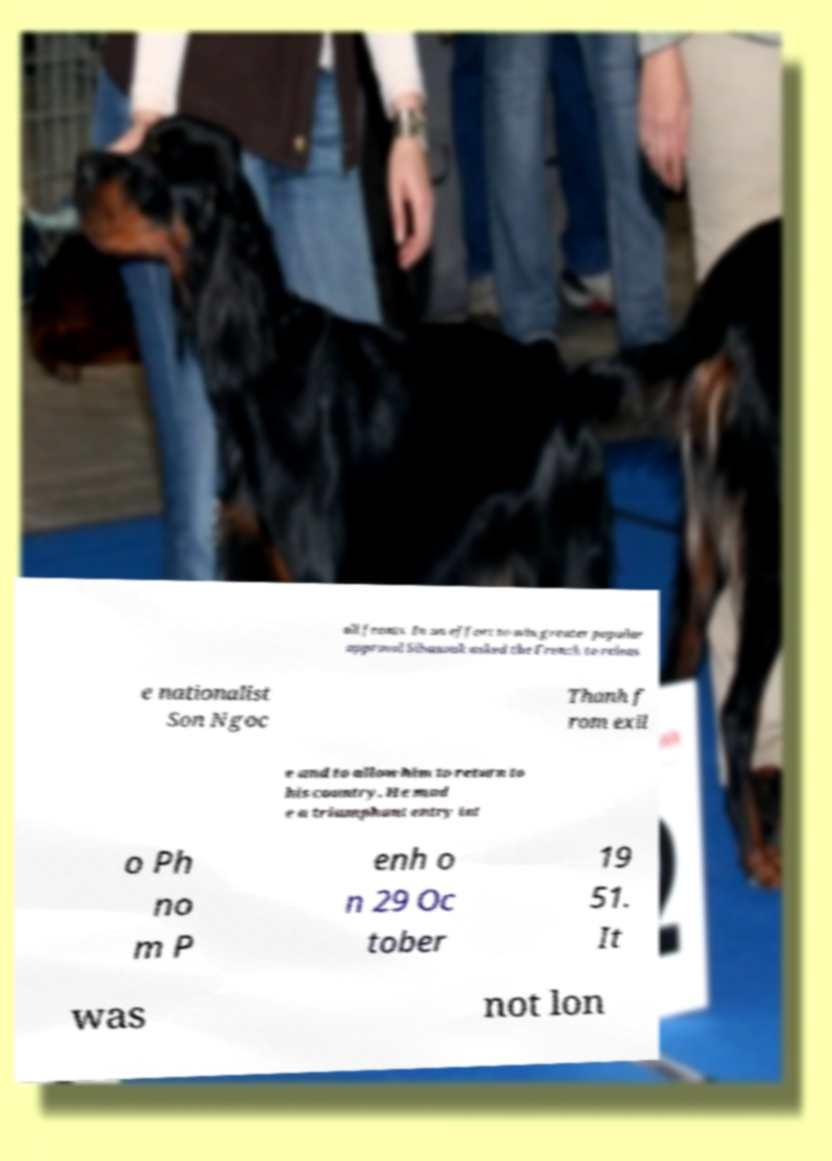For documentation purposes, I need the text within this image transcribed. Could you provide that? all fronts. In an effort to win greater popular approval Sihanouk asked the French to releas e nationalist Son Ngoc Thanh f rom exil e and to allow him to return to his country. He mad e a triumphant entry int o Ph no m P enh o n 29 Oc tober 19 51. It was not lon 